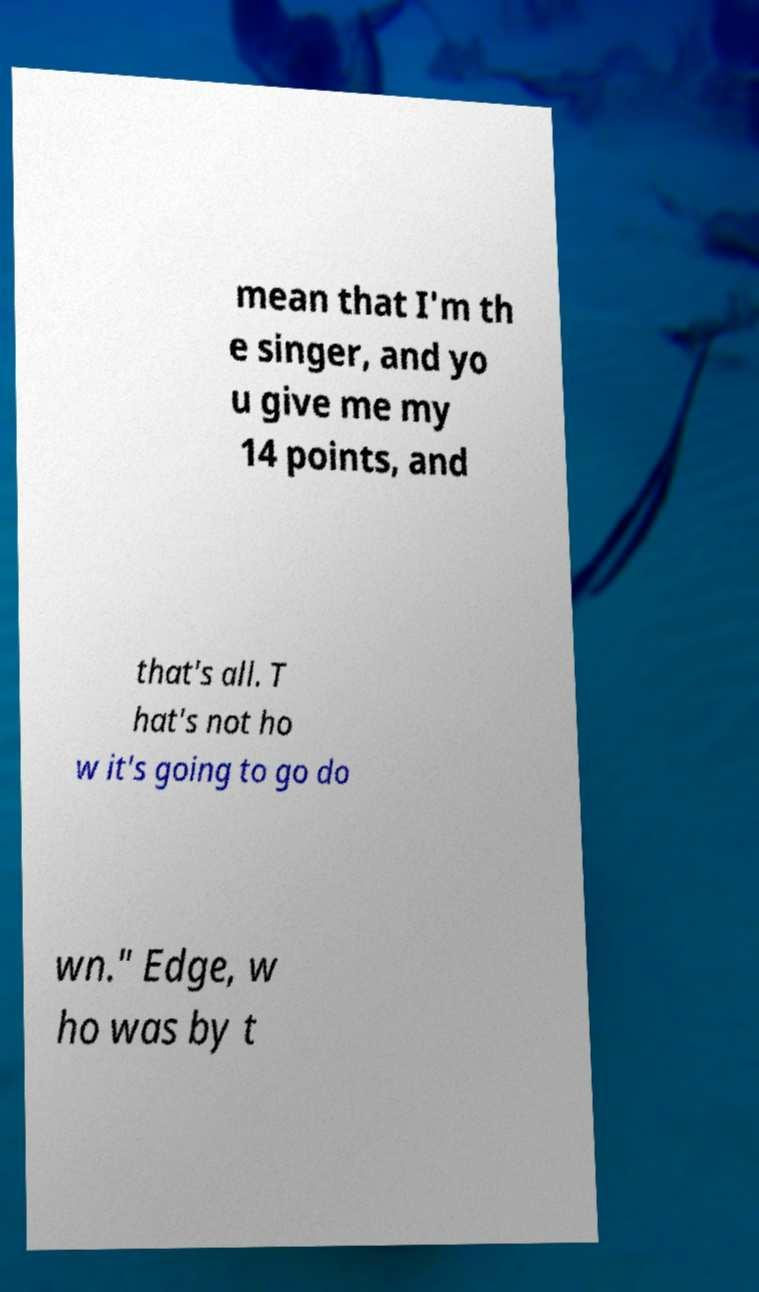Could you assist in decoding the text presented in this image and type it out clearly? mean that I'm th e singer, and yo u give me my 14 points, and that's all. T hat's not ho w it's going to go do wn." Edge, w ho was by t 